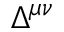Convert formula to latex. <formula><loc_0><loc_0><loc_500><loc_500>\Delta ^ { \mu \nu }</formula> 